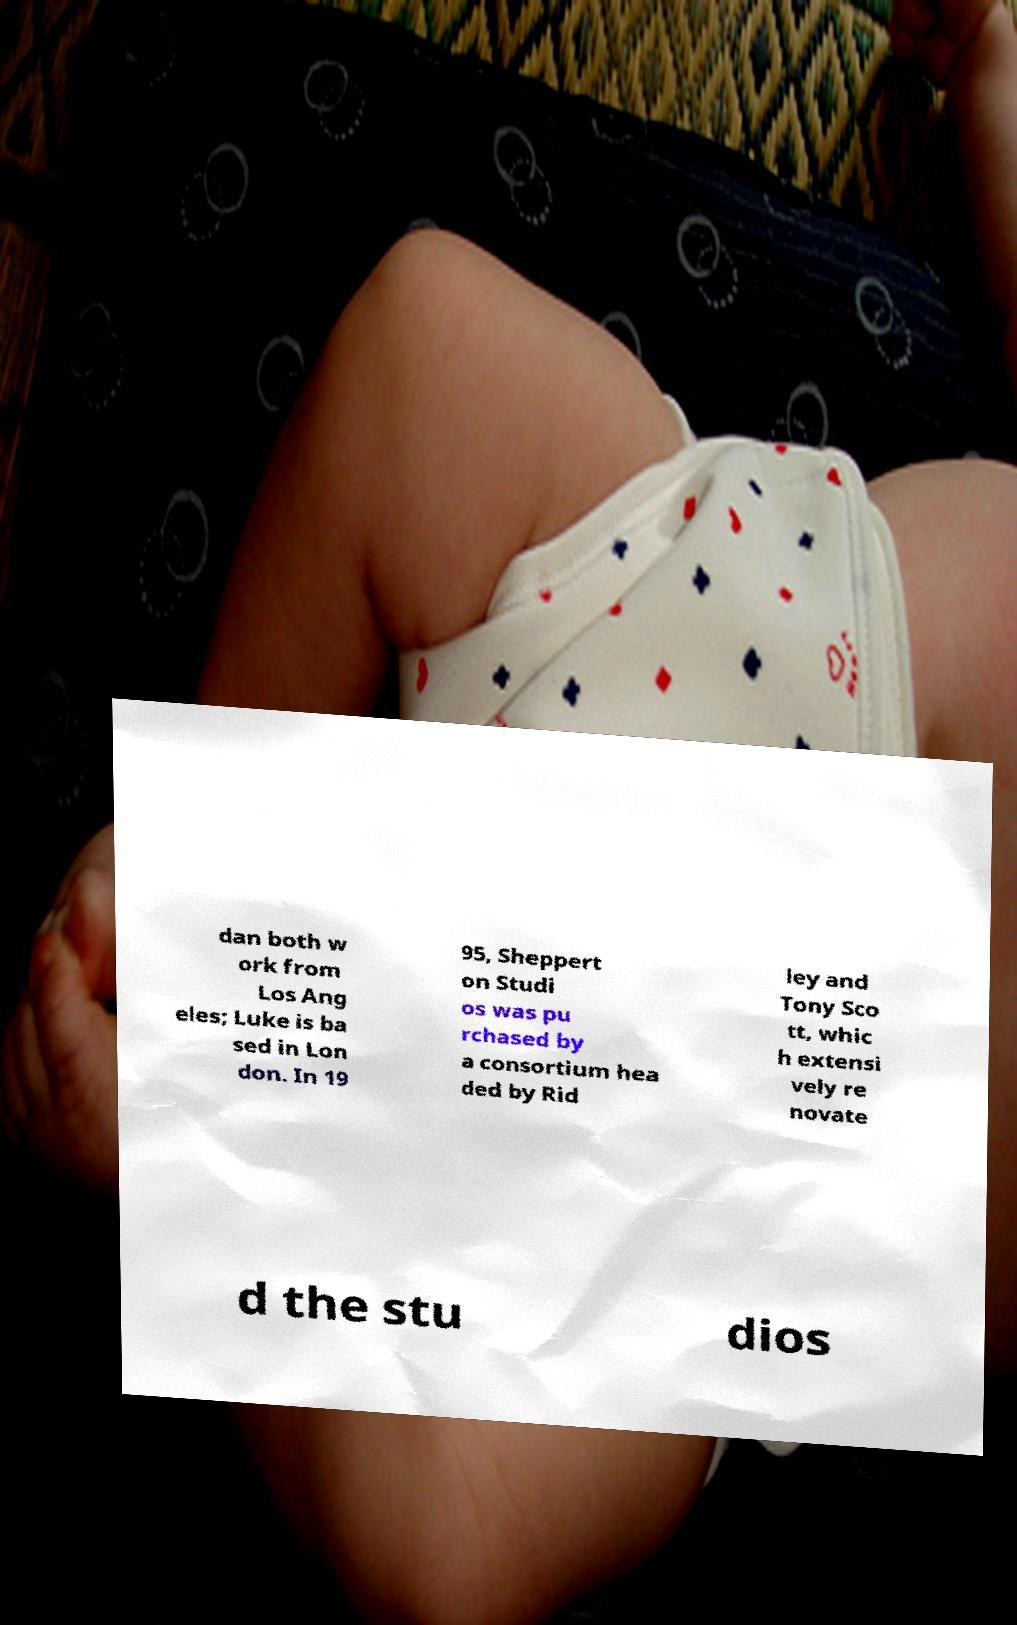Please read and relay the text visible in this image. What does it say? dan both w ork from Los Ang eles; Luke is ba sed in Lon don. In 19 95, Sheppert on Studi os was pu rchased by a consortium hea ded by Rid ley and Tony Sco tt, whic h extensi vely re novate d the stu dios 